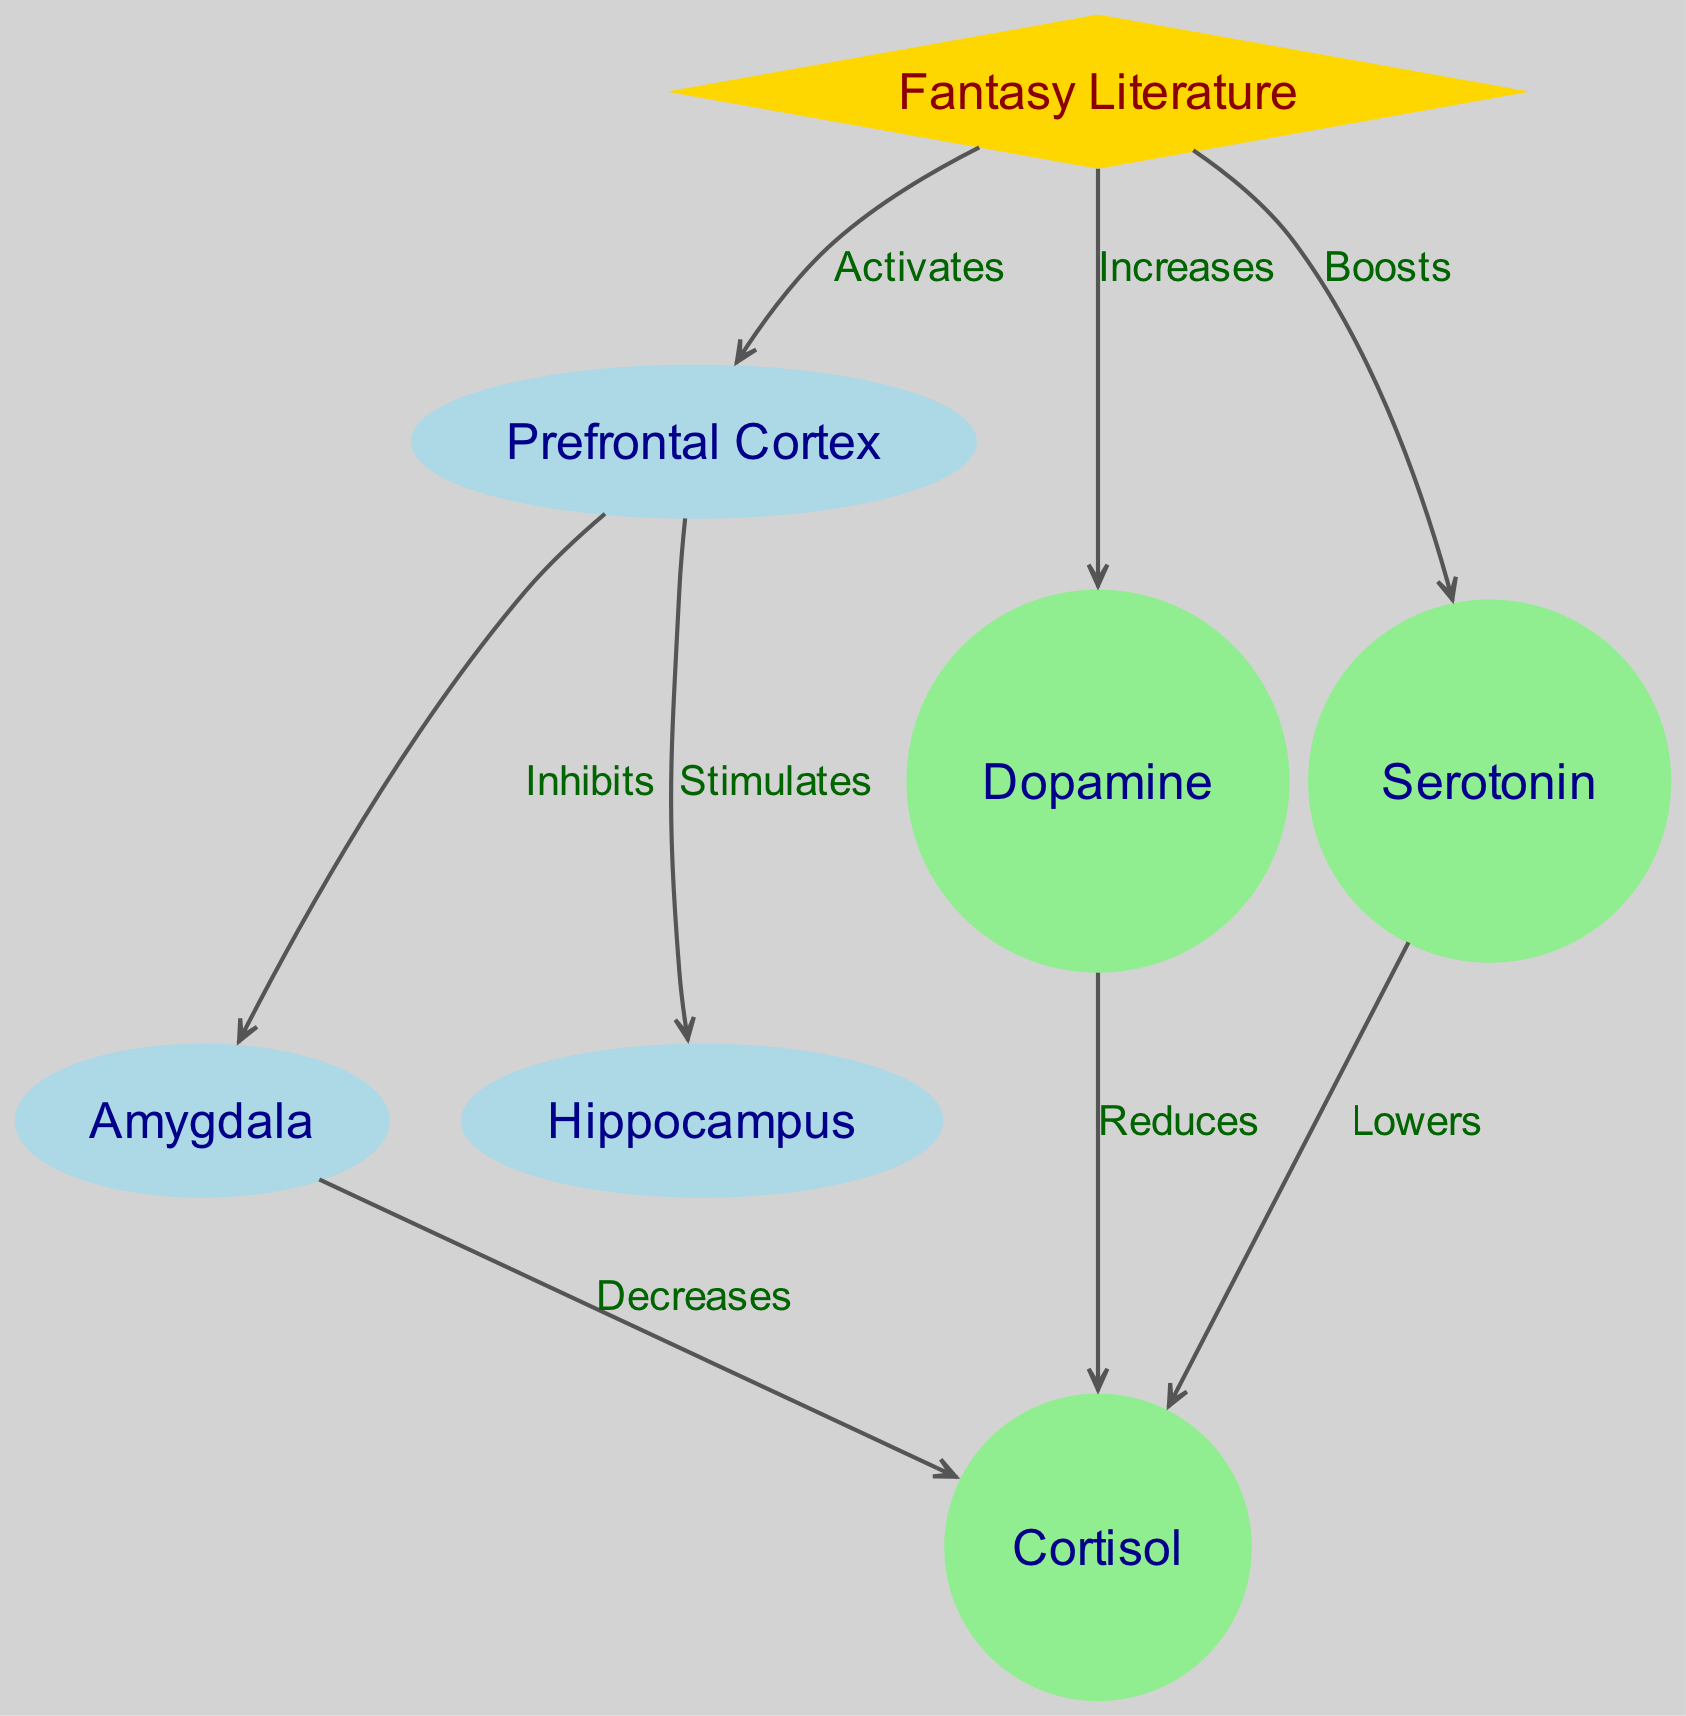What is the main element that activates the Prefrontal Cortex? According to the diagram, "Fantasy Literature" is shown as the activating factor for the Prefrontal Cortex since there is a direct edge labeled "Activates" between these two nodes.
Answer: Fantasy Literature How many nodes are present in the diagram? The diagram contains seven nodes, which are labeled Fantasy Literature, Prefrontal Cortex, Amygdala, Hippocampus, Dopamine, Serotonin, and Cortisol.
Answer: Seven Which neurochemical is reduced by Dopamine? The diagram indicates that Dopamine has a direct edge labeled "Reduces" that leads to Cortisol, signifying that Dopamine reduces Cortisol levels.
Answer: Cortisol What effect does the Prefrontal Cortex have on the Amygdala? The diagram shows that the Prefrontal Cortex "Inhibits" the Amygdala, indicated by the direct edge labeled "Inhibits" connecting these two nodes.
Answer: Inhibits Which two neurochemicals are shown to lower Cortisol? The diagram illustrates two neurochemicals, Dopamine and Serotonin, both of which have edges labeled "Reduces" and "Lowers," respectively, connecting to Cortisol.
Answer: Dopamine and Serotonin What is the relationship between Fantasy Literature and Serotonin? The diagram depicts that Fantasy Literature "Boosts" Serotonin as indicated by the direct edge connecting these two nodes.
Answer: Boosts What is the effect of the Prefrontal Cortex on the Hippocampus? The diagram clearly states that the Prefrontal Cortex "Stimulates" the Hippocampus based on the edge labeled "Stimulates" connecting these two nodes.
Answer: Stimulates Which node is indicated to decrease Cortisol? The diagram shows that the Amygdala has a direct edge labeled "Decreases" pointing to Cortisol, indicating that actions or states related to the Amygdala result in a decrease in Cortisol levels.
Answer: Amygdala How is stress generally indicated to be reduced according to this diagram? The diagram suggests that stress reduction occurs through pathways involving increases in Dopamine and Serotonin, alongside the inhibiting effects on the Amygdala, which is linked to a reduction in Cortisol.
Answer: Through increases in Dopamine and Serotonin 